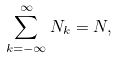Convert formula to latex. <formula><loc_0><loc_0><loc_500><loc_500>\sum _ { k = - \infty } ^ { \infty } N _ { k } = N ,</formula> 